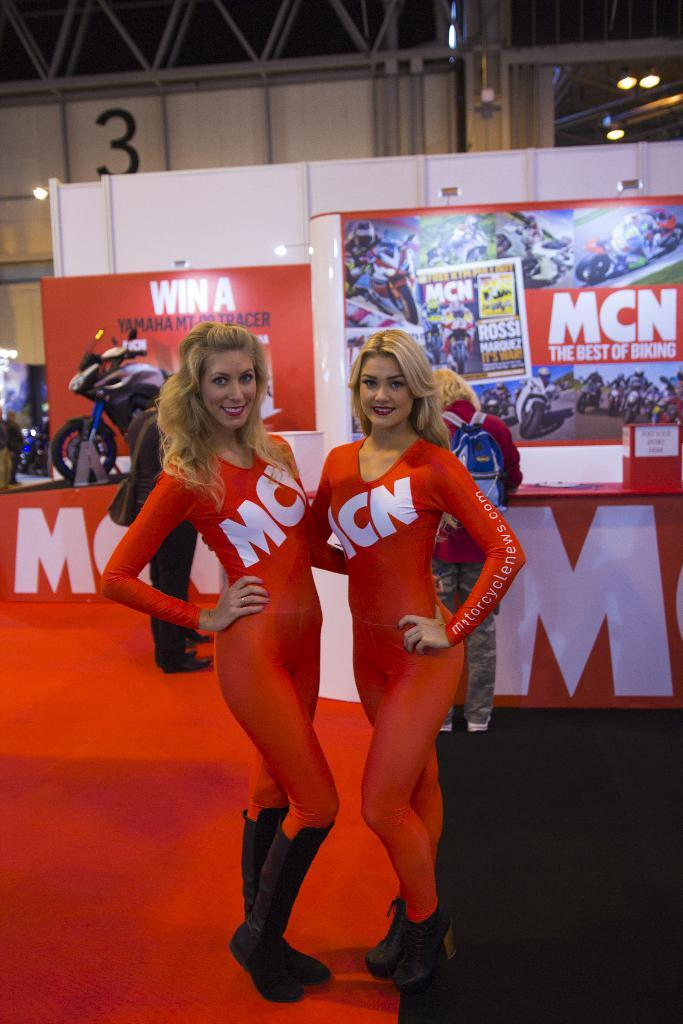<image>
Summarize the visual content of the image. 2 women wearing skin-tight MCN outfits are standing in front of the MCN display wall. 